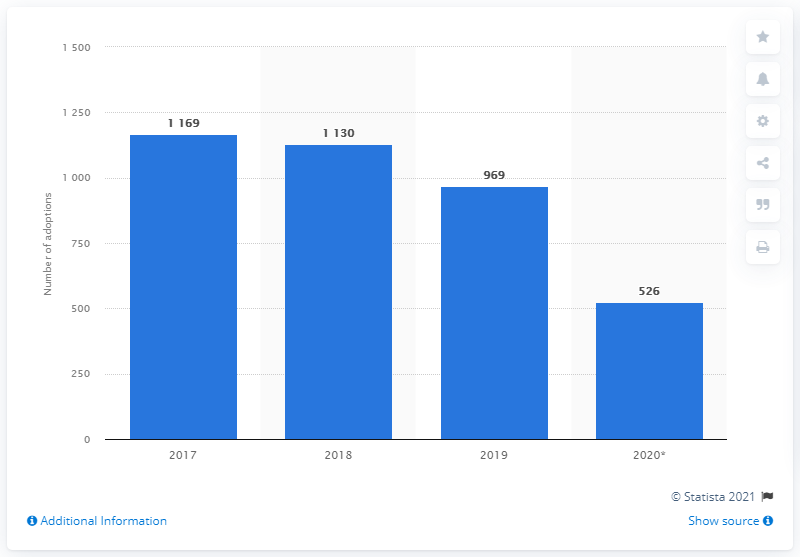Identify some key points in this picture. In 2020, there were 526 international adoptions in Italy. 